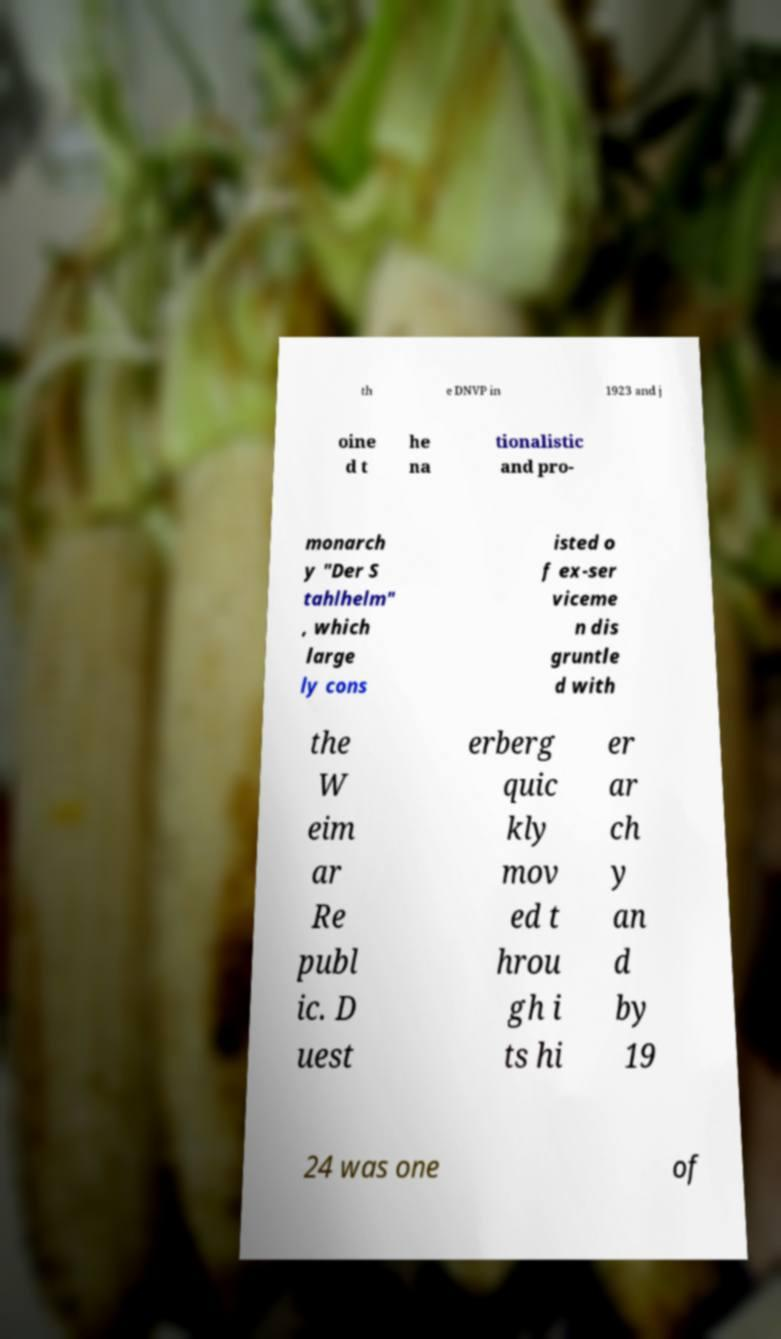Can you accurately transcribe the text from the provided image for me? th e DNVP in 1923 and j oine d t he na tionalistic and pro- monarch y "Der S tahlhelm" , which large ly cons isted o f ex-ser viceme n dis gruntle d with the W eim ar Re publ ic. D uest erberg quic kly mov ed t hrou gh i ts hi er ar ch y an d by 19 24 was one of 